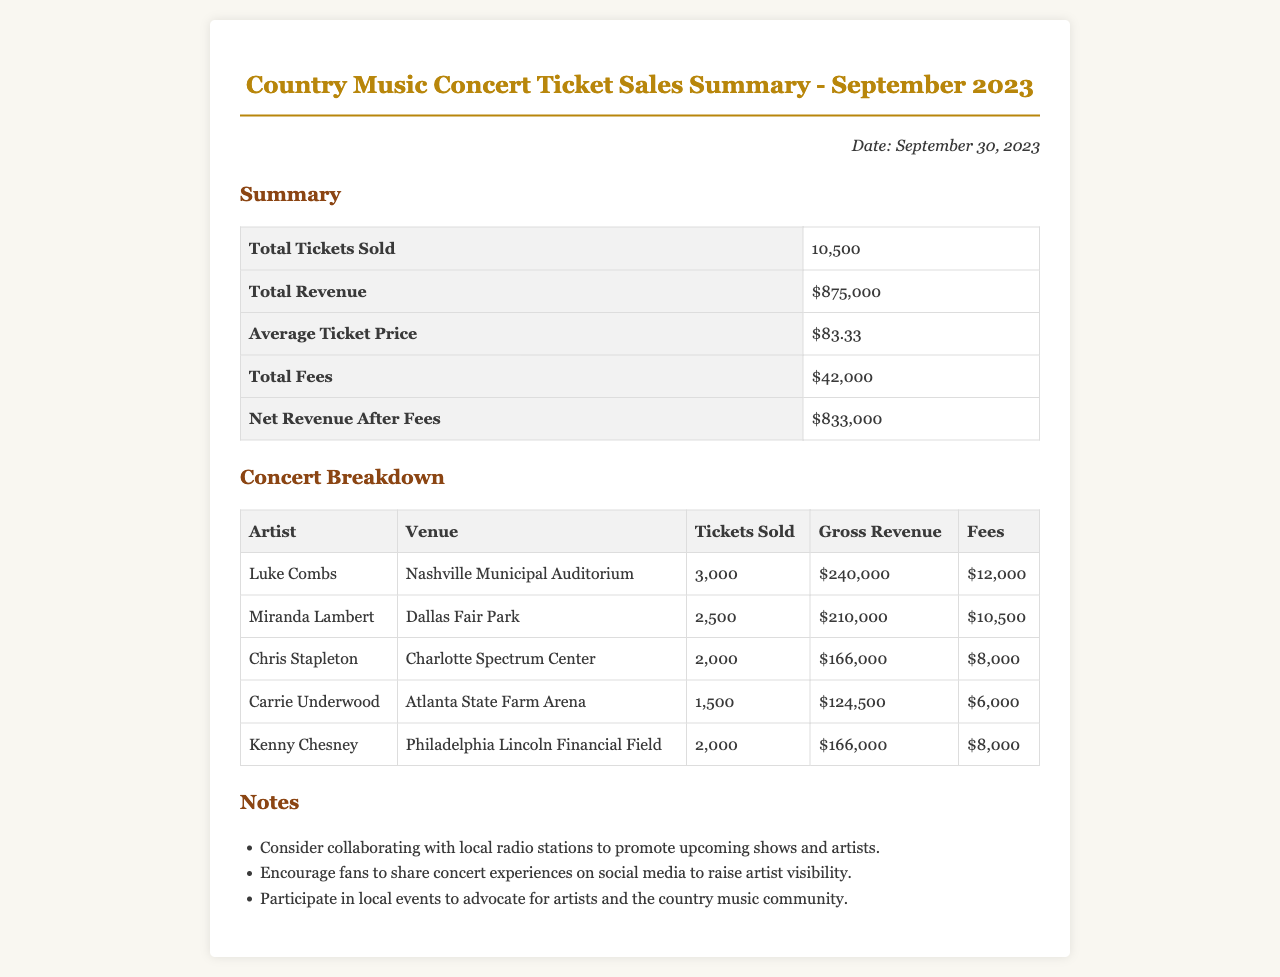What is the total number of tickets sold? The total number of tickets sold is listed in the summary section of the document.
Answer: 10,500 What was the total revenue? The total revenue is stated in the summary section and represents the overall earnings from ticket sales.
Answer: $875,000 How many tickets did Luke Combs sell? The tickets sold for Luke Combs are provided in the concert breakdown section of the document.
Answer: 3,000 What are the total fees for September 2023? The total fees are summarized in the document and represent the total costs associated with the ticket sales.
Answer: $42,000 What is the average ticket price? The average ticket price is calculated as part of the summary section, reflecting the average cost of tickets sold.
Answer: $83.33 Which artist sold tickets at the Charlotte Spectrum Center? The artist associated with the Charlotte Spectrum Center is mentioned in the concert breakdown section.
Answer: Chris Stapleton How much revenue did Miranda Lambert generate? The gross revenue for Miranda Lambert is detailed in the concert breakdown section of the document.
Answer: $210,000 What is the net revenue after fees? The net revenue after subtracting fees is highlighted in the summary section of the document.
Answer: $833,000 What is one suggestion for promoting artists mentioned in the notes? Suggestions for promoting artists are listed in the notes section of the document; one is to collaborate with local radio stations.
Answer: Collaborating with local radio stations 